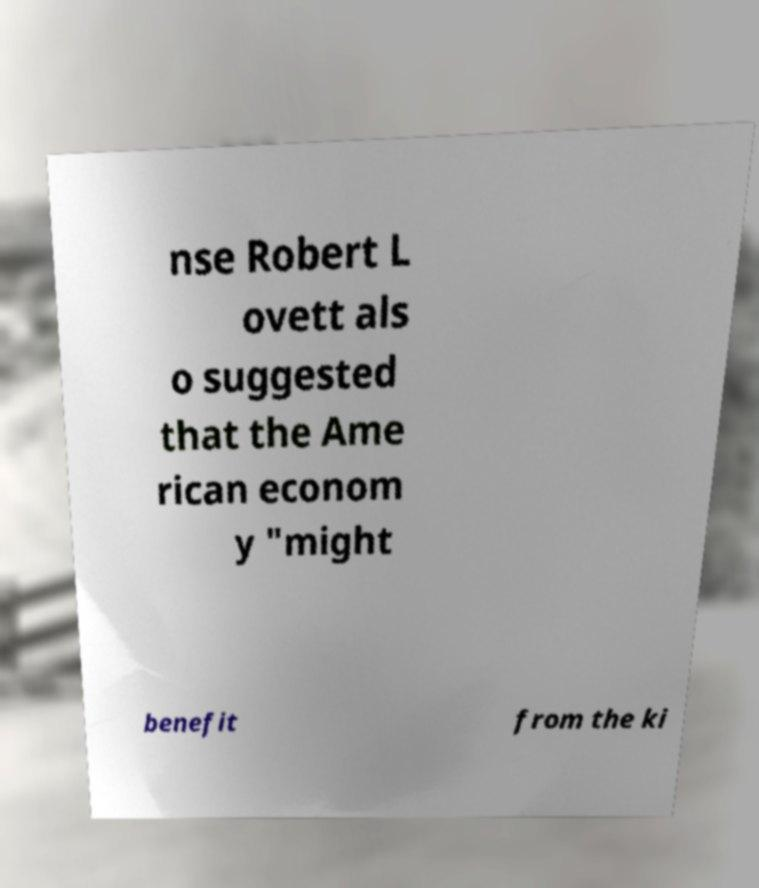Could you assist in decoding the text presented in this image and type it out clearly? nse Robert L ovett als o suggested that the Ame rican econom y "might benefit from the ki 